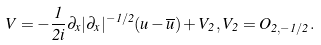<formula> <loc_0><loc_0><loc_500><loc_500>V = - \frac { 1 } { 2 i } \partial _ { x } | \partial _ { x } | ^ { - 1 / 2 } ( u - \overline { u } ) + V _ { 2 } , V _ { 2 } = O _ { 2 , - 1 / 2 } .</formula> 